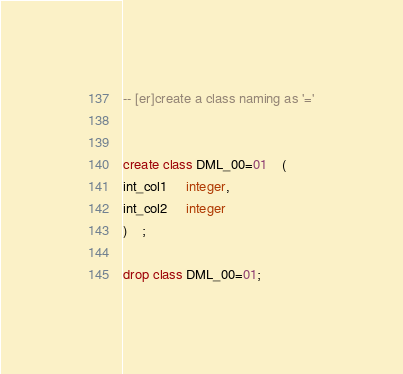<code> <loc_0><loc_0><loc_500><loc_500><_SQL_>-- [er]create a class naming as '='


create class DML_00=01 	( 
int_col1	 integer,
int_col2	 integer
)	;

drop class DML_00=01;
</code> 